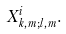<formula> <loc_0><loc_0><loc_500><loc_500>X ^ { i } _ { k , m ; l , m } .</formula> 